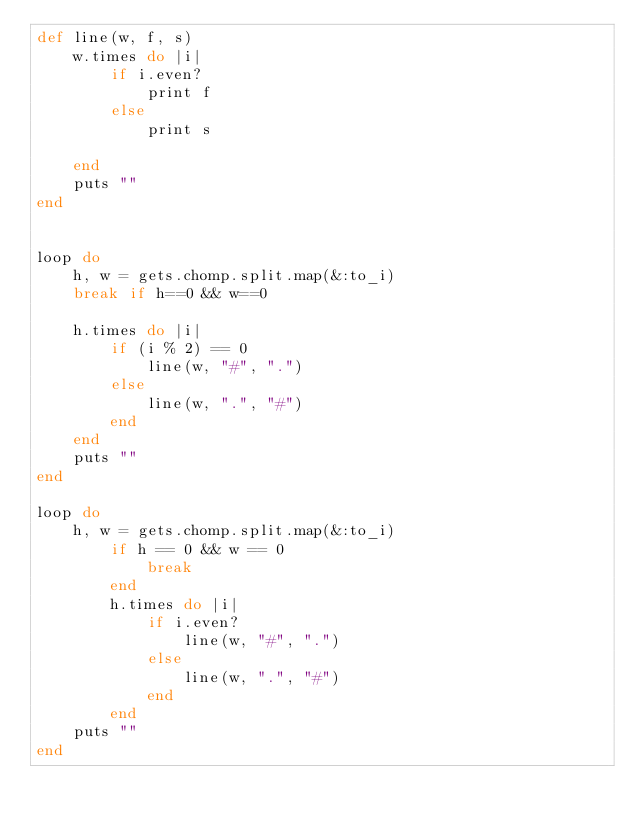Convert code to text. <code><loc_0><loc_0><loc_500><loc_500><_Ruby_>def line(w, f, s)
    w.times do |i|
        if i.even?
            print f
        else
            print s
        
    end
    puts ""
end


loop do
    h, w = gets.chomp.split.map(&:to_i)
    break if h==0 && w==0

    h.times do |i|
        if (i % 2) == 0
            line(w, "#", ".")
        else
            line(w, ".", "#")
        end
    end
    puts ""
end

loop do
    h, w = gets.chomp.split.map(&:to_i)
        if h == 0 && w == 0
            break
        end
        h.times do |i|
            if i.even?
                line(w, "#", ".")
            else
                line(w, ".", "#")
            end
        end
    puts ""
end</code> 